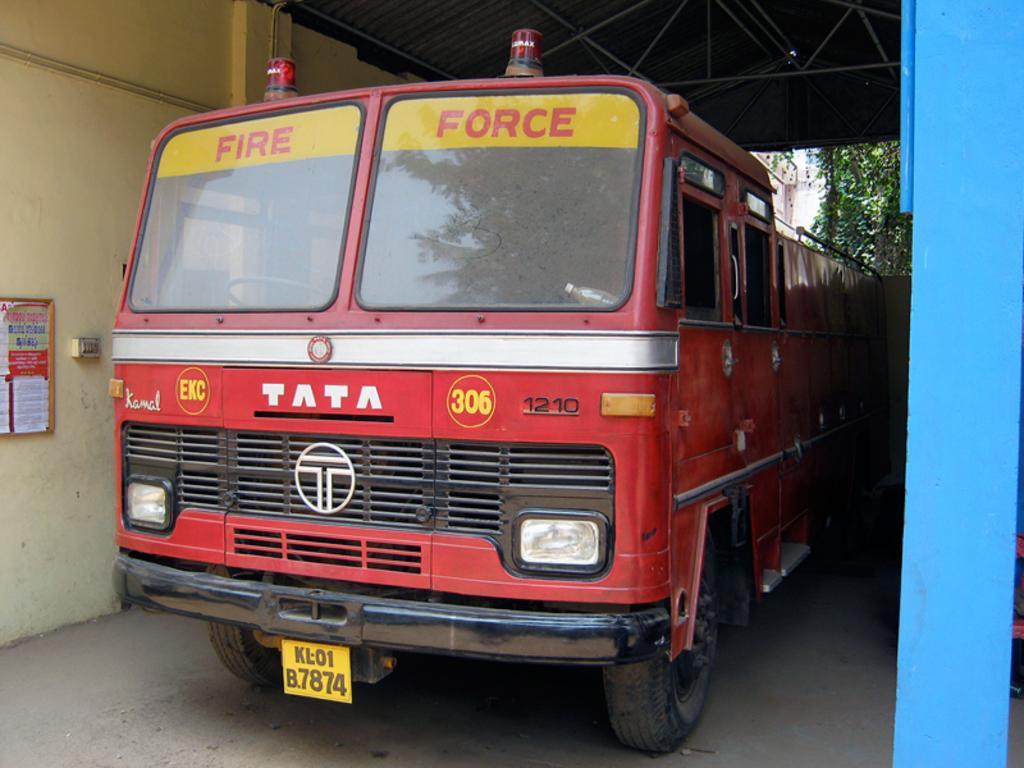How would you summarize this image in a sentence or two? In this image there is a vehicle under the shed. There is a wall on the left side. There are trees and building in the background. There is a blue color pillar on the right side. 